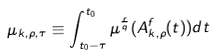<formula> <loc_0><loc_0><loc_500><loc_500>\mu _ { k , \rho , \tau } \equiv \int _ { t _ { 0 } - \tau } ^ { t _ { 0 } } \mu ^ { \frac { r } { q } } ( A ^ { f } _ { k , \rho } ( t ) ) d t</formula> 